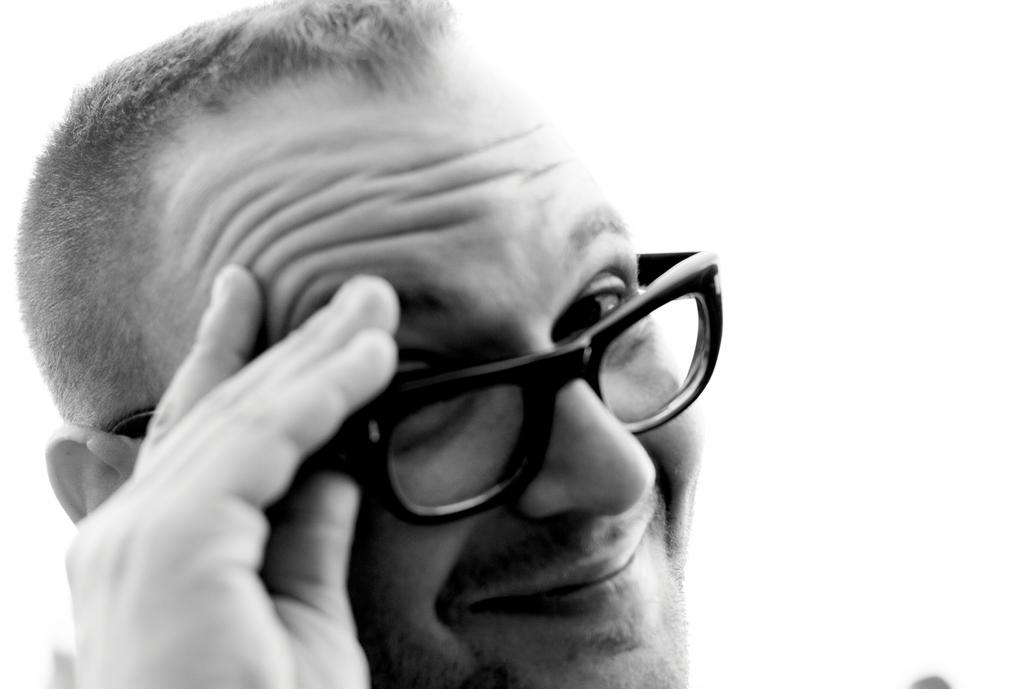What is the color scheme of the image? The image is black and white. What is the main subject of the image? There is a man in the image. What accessory is the man wearing in the image? The man is wearing glasses. What type of bird can be seen flying in the image? There is no bird present in the image; it only features a man wearing glasses. What scent can be detected coming from the man in the image? There is no mention of any scent in the image, as it only shows a man wearing glasses. 